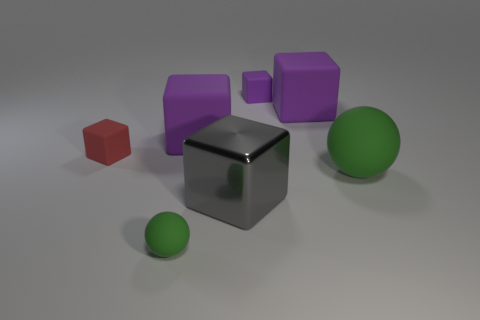Subtract all purple cubes. How many were subtracted if there are1purple cubes left? 2 Subtract all yellow balls. How many purple blocks are left? 3 Subtract all large gray blocks. How many blocks are left? 4 Subtract all red blocks. How many blocks are left? 4 Subtract all gray blocks. Subtract all purple cylinders. How many blocks are left? 4 Add 2 big purple rubber things. How many objects exist? 9 Subtract all spheres. How many objects are left? 5 Add 6 large metal cubes. How many large metal cubes are left? 7 Add 1 cyan rubber cylinders. How many cyan rubber cylinders exist? 1 Subtract 1 purple cubes. How many objects are left? 6 